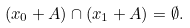<formula> <loc_0><loc_0><loc_500><loc_500>( x _ { 0 } + A ) \cap ( x _ { 1 } + A ) = \emptyset .</formula> 